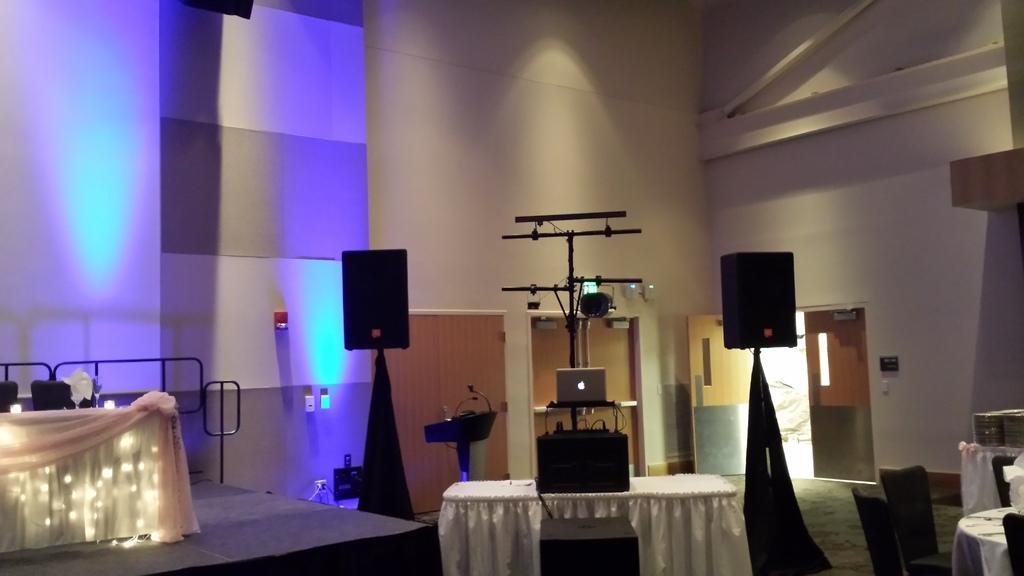Describe this image in one or two sentences. In this image I can see on the left side it looks like a stage, there are chairs and table on the stage. In the middle there is a laptop and there are two speakers. On the right side it looks like a door. 